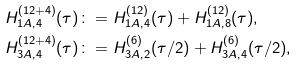Convert formula to latex. <formula><loc_0><loc_0><loc_500><loc_500>H ^ { ( 1 2 + 4 ) } _ { 1 A , 4 } ( \tau ) & \colon = H ^ { ( 1 2 ) } _ { 1 A , 4 } ( \tau ) + H ^ { ( 1 2 ) } _ { 1 A , 8 } ( \tau ) , \\ H ^ { ( 1 2 + 4 ) } _ { 3 A , 4 } ( \tau ) & \colon = H ^ { ( 6 ) } _ { 3 A , 2 } ( \tau / 2 ) + H ^ { ( 6 ) } _ { 3 A , 4 } ( \tau / 2 ) , \\</formula> 